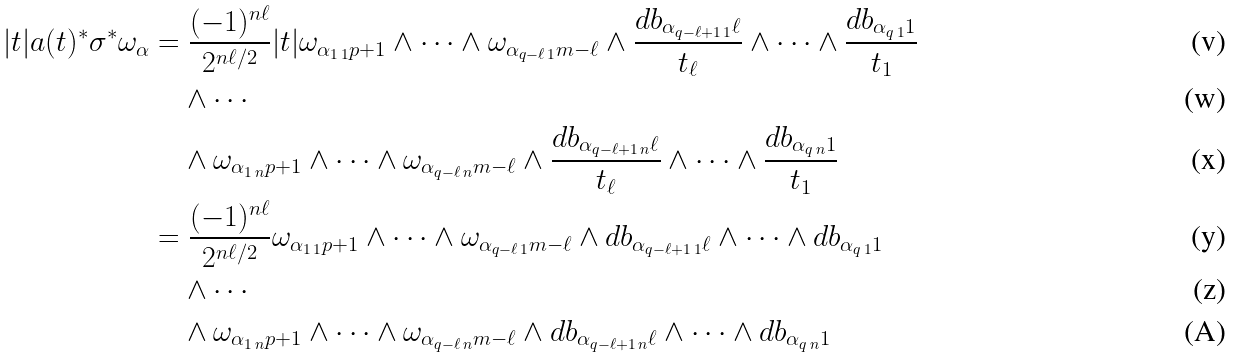Convert formula to latex. <formula><loc_0><loc_0><loc_500><loc_500>| t | a ( t ) ^ { \ast } \sigma ^ { \ast } \omega _ { \alpha } & = \frac { ( - 1 ) ^ { n \ell } } { 2 ^ { n \ell / 2 } } | t | \omega _ { \alpha _ { 1 \, 1 } p + 1 } \wedge \cdots \wedge \omega _ { \alpha _ { q - \ell \, 1 } m - \ell } \wedge \frac { d b _ { \alpha _ { q - \ell + 1 \, 1 } \ell } } { t _ { \ell } } \wedge \cdots \wedge \frac { d b _ { \alpha _ { q \, 1 } 1 } } { t _ { 1 } } \\ & \quad \wedge \cdots \\ & \quad \wedge \omega _ { \alpha _ { 1 \, n } p + 1 } \wedge \cdots \wedge \omega _ { \alpha _ { q - \ell \, n } m - \ell } \wedge \frac { d b _ { \alpha _ { q - \ell + 1 \, n } \ell } } { t _ { \ell } } \wedge \cdots \wedge \frac { d b _ { \alpha _ { q \, n } 1 } } { t _ { 1 } } \\ & = \frac { ( - 1 ) ^ { n \ell } } { 2 ^ { n \ell / 2 } } \omega _ { \alpha _ { 1 \, 1 } p + 1 } \wedge \cdots \wedge \omega _ { \alpha _ { q - \ell \, 1 } m - \ell } \wedge d b _ { \alpha _ { q - \ell + 1 \, 1 } \ell } \wedge \cdots \wedge d b _ { \alpha _ { q \, 1 } 1 } \\ & \quad \wedge \cdots \\ & \quad \wedge \omega _ { \alpha _ { 1 \, n } p + 1 } \wedge \cdots \wedge \omega _ { \alpha _ { q - \ell \, n } m - \ell } \wedge d b _ { \alpha _ { q - \ell + 1 \, n } \ell } \wedge \cdots \wedge d b _ { \alpha _ { q \, n } 1 }</formula> 